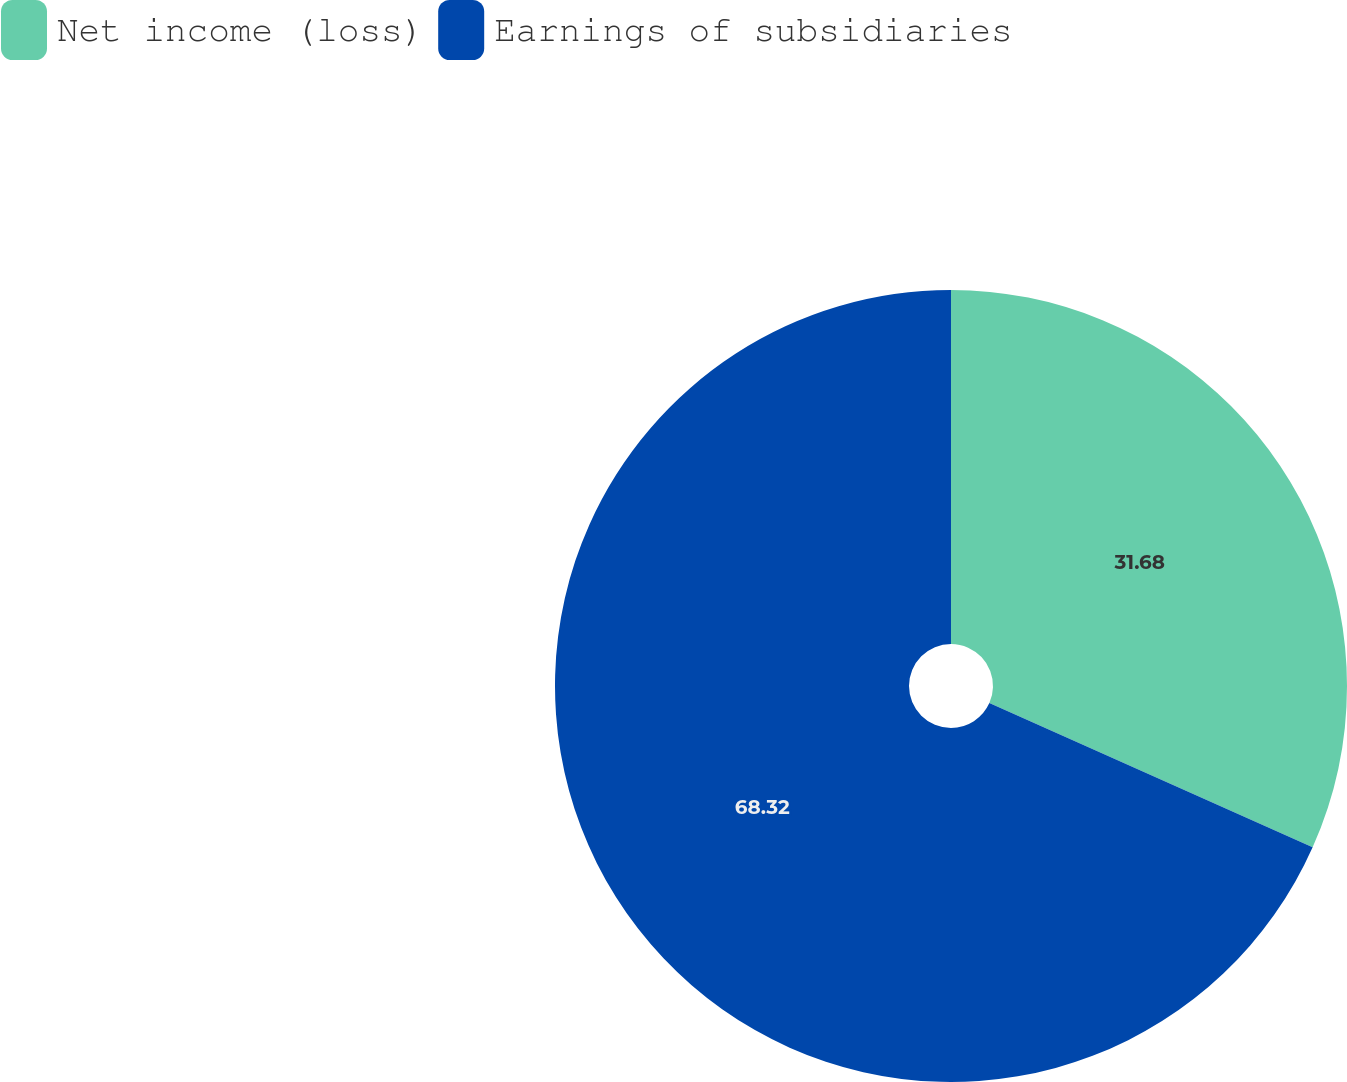<chart> <loc_0><loc_0><loc_500><loc_500><pie_chart><fcel>Net income (loss)<fcel>Earnings of subsidiaries<nl><fcel>31.68%<fcel>68.32%<nl></chart> 